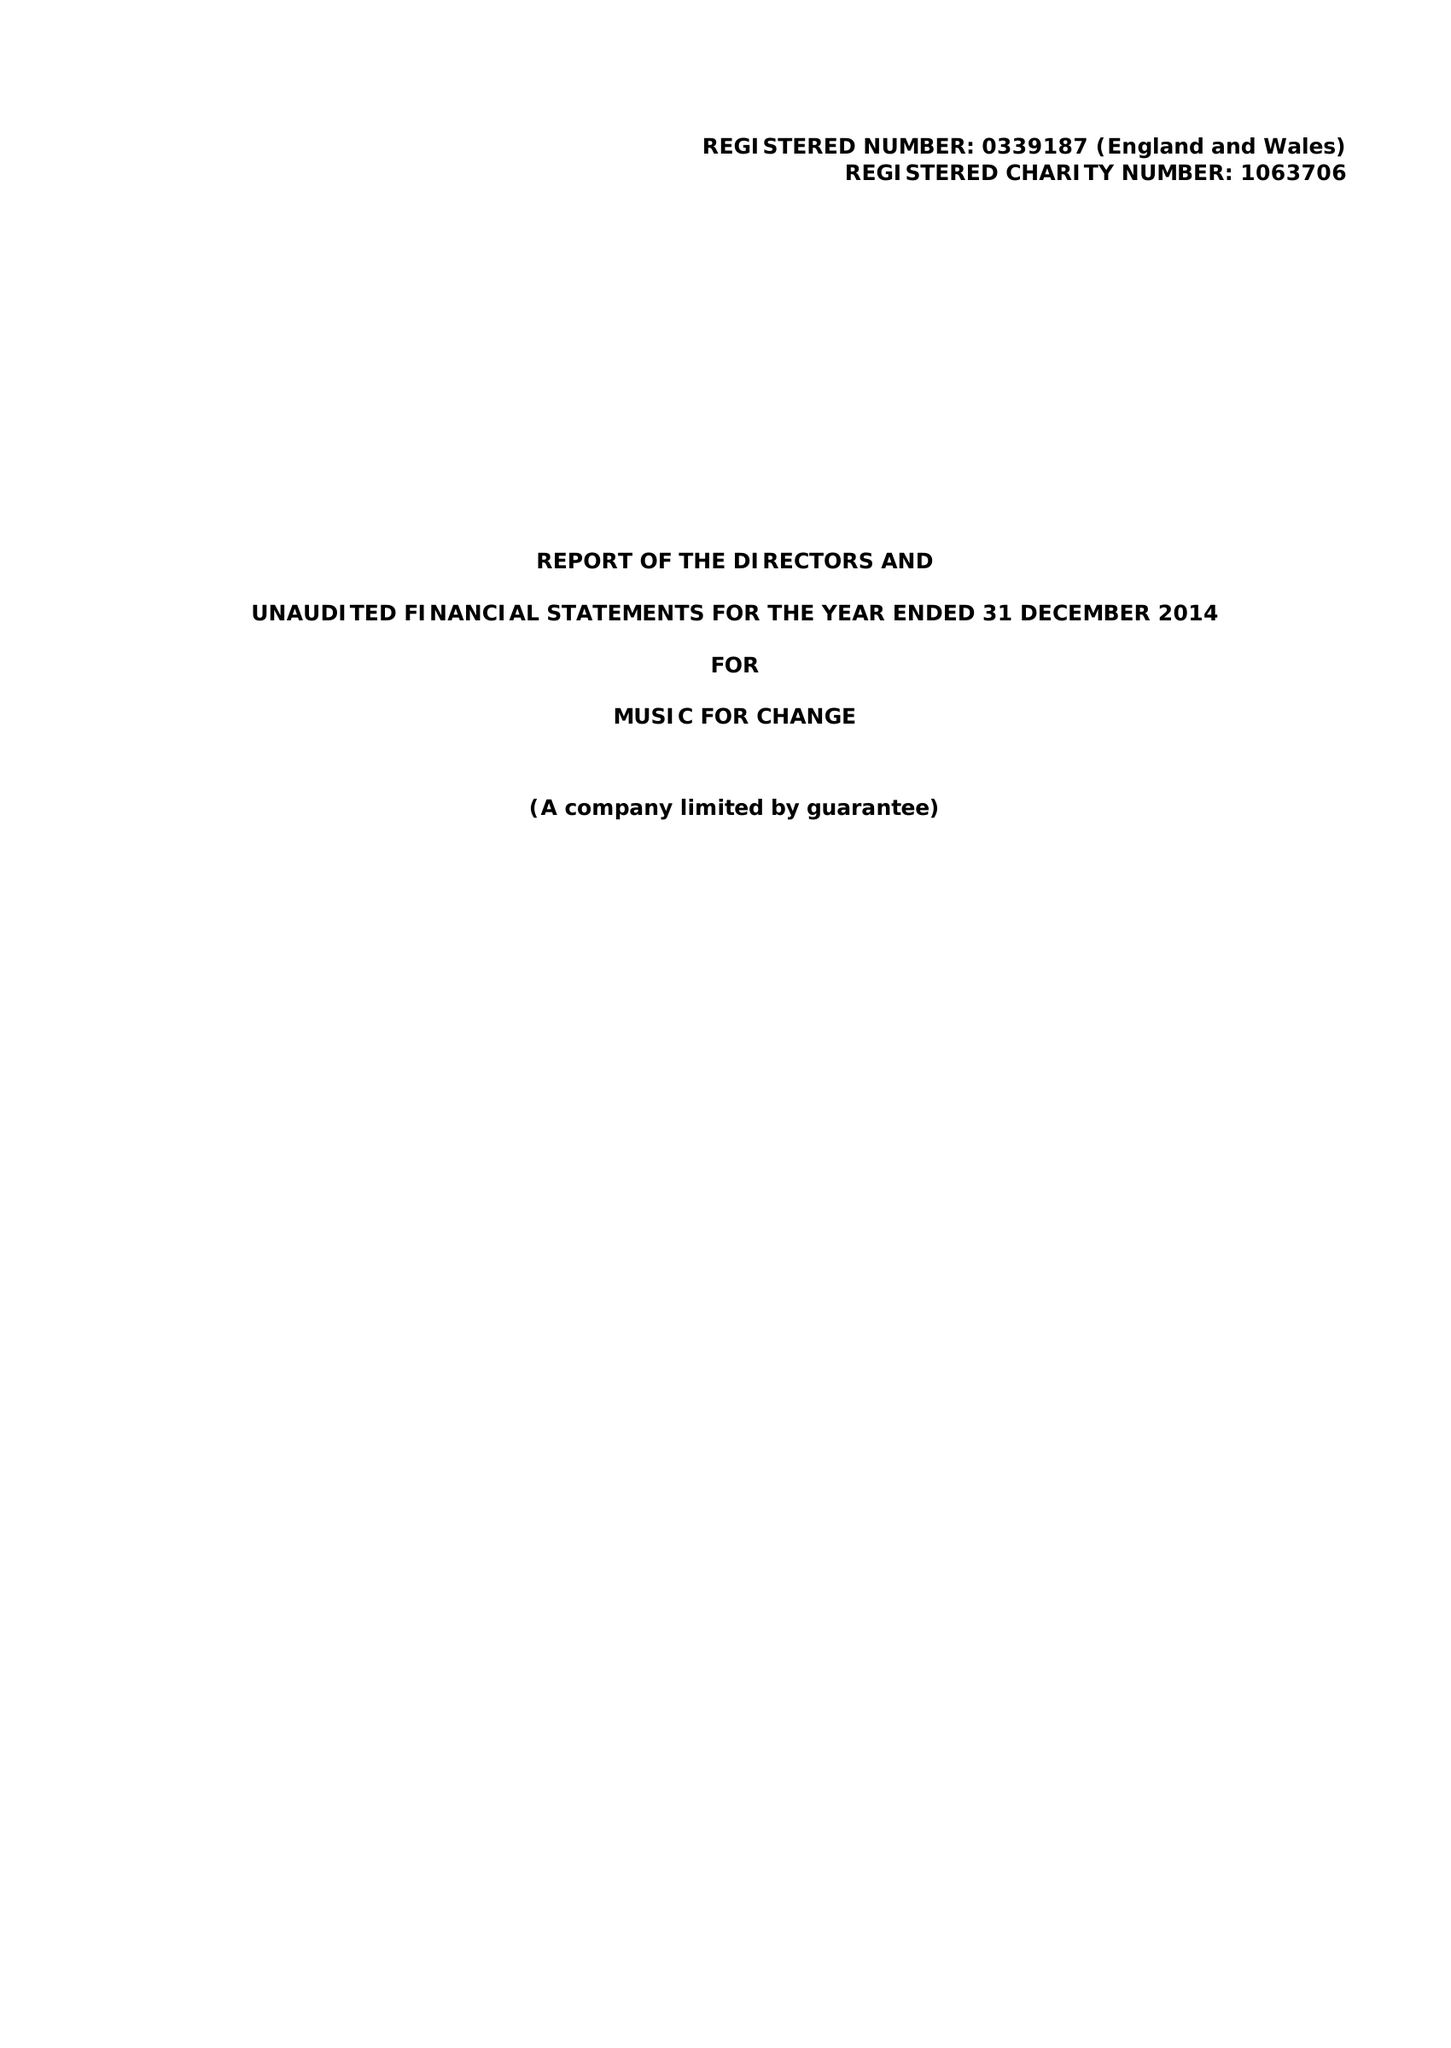What is the value for the charity_number?
Answer the question using a single word or phrase. 1063706 